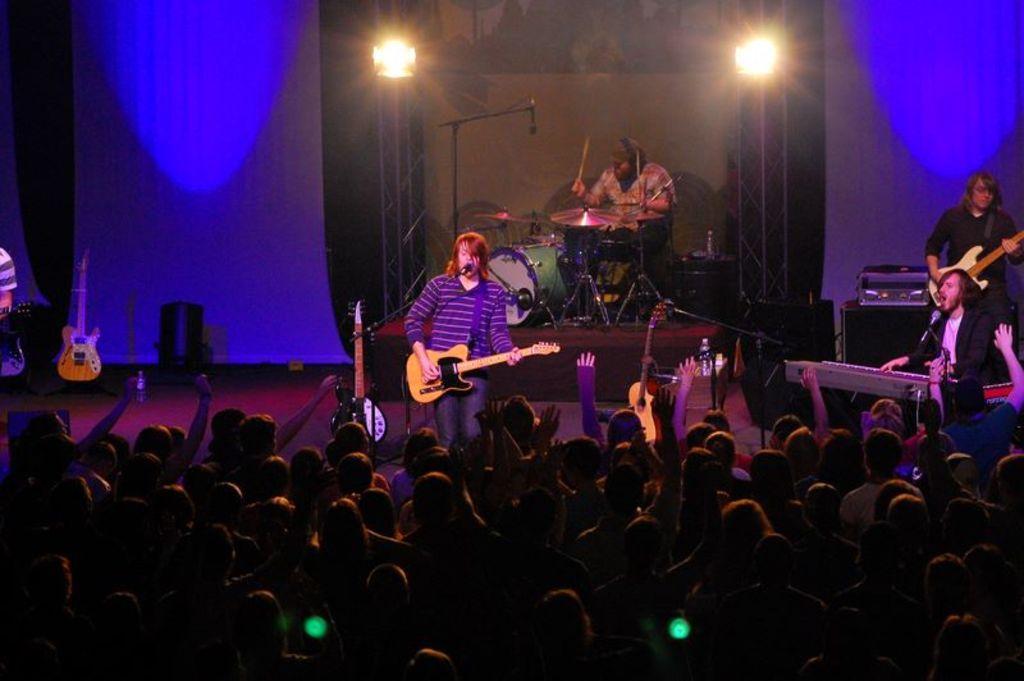In one or two sentences, can you explain what this image depicts? Here we can see a man is standing on the stage and singing and holding guitar in his hands, and at back here a person is sitting and playing musical drums, and here a person is playing piano, and here a group of people standing, and here are the lights. 